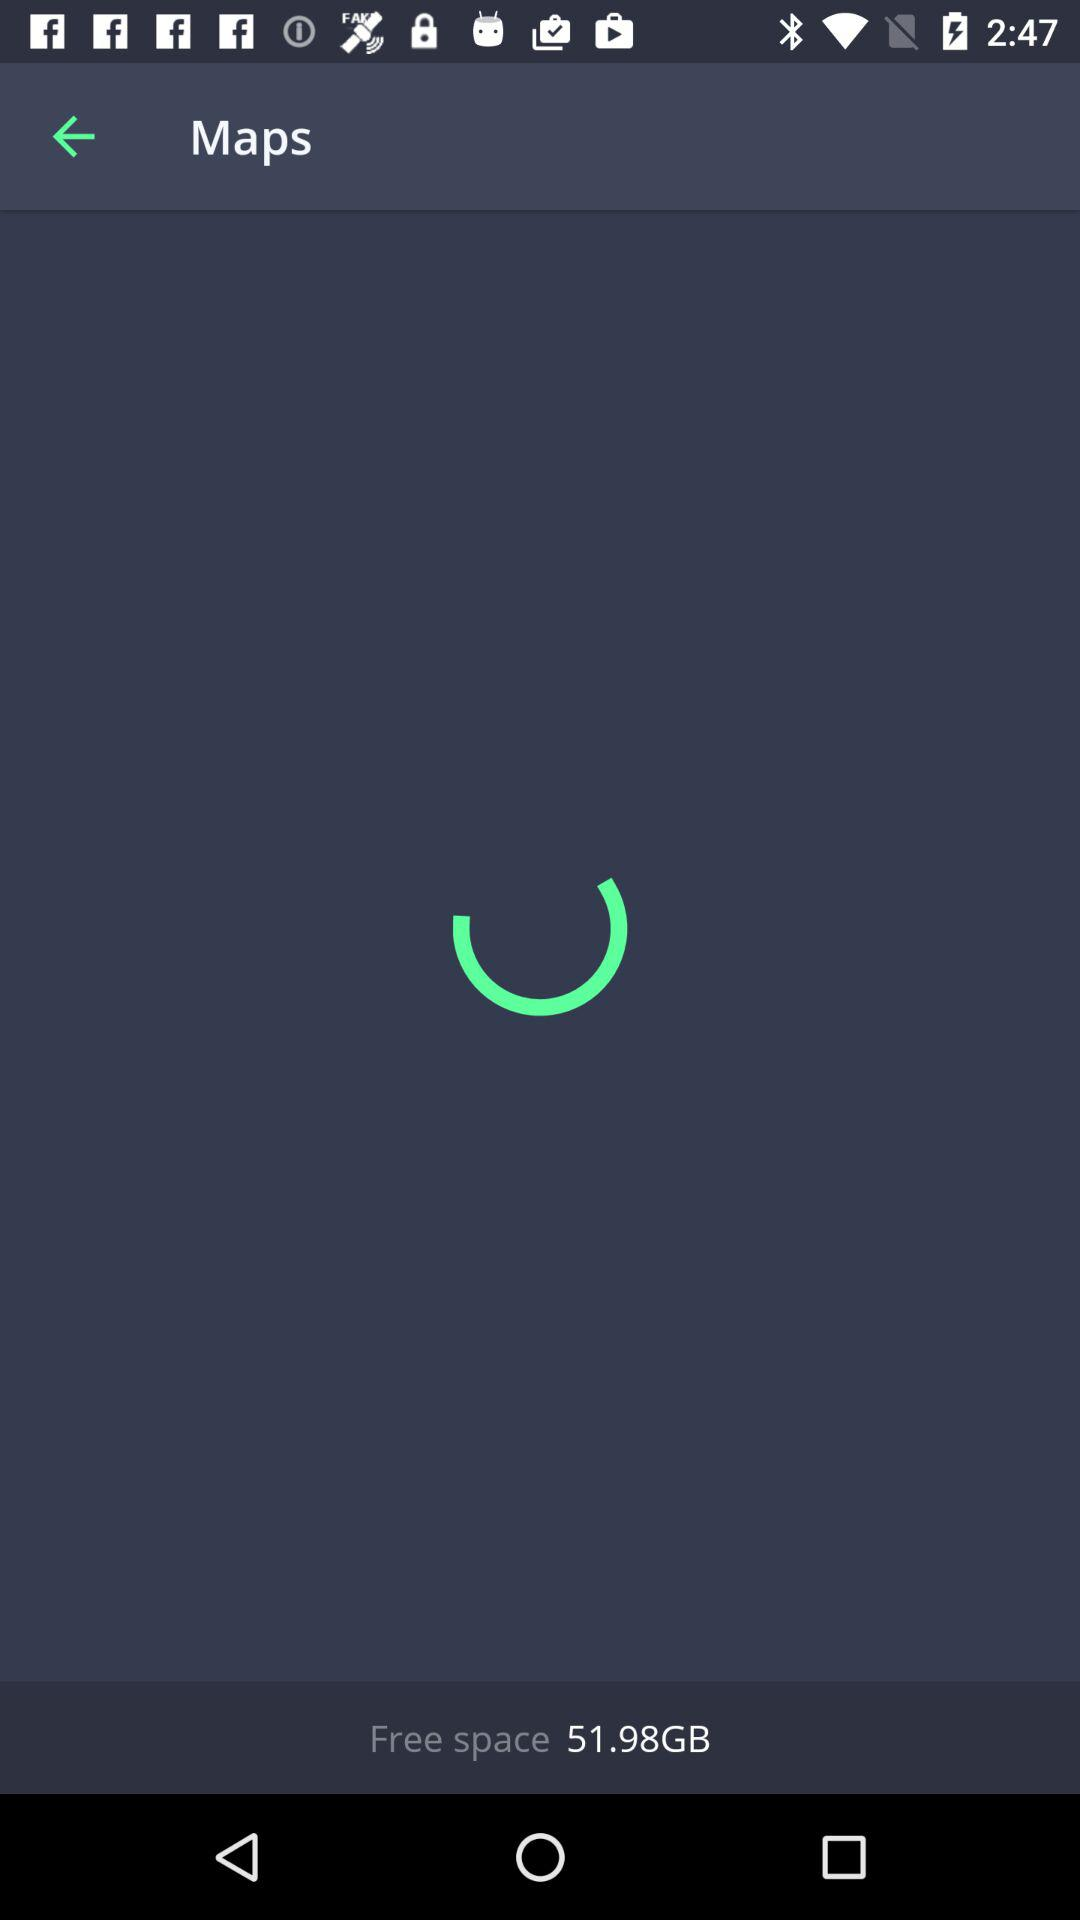How much free space is available?
Answer the question using a single word or phrase. 51.98GB 